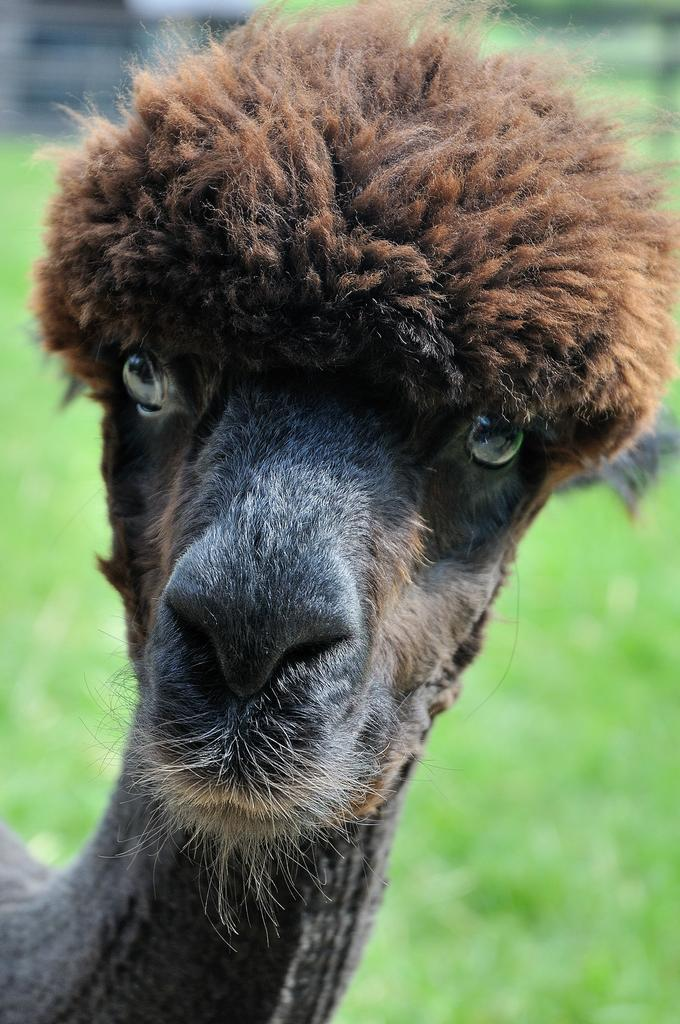What type of creature is present in the image? There is an animal in the image. What color is the animal? The animal is brown in color. What can be seen in the background of the image? The background of the image includes green grass. What type of fireman is sitting on the cushion in the image? There is no fireman or cushion present in the image; it features an animal and green grass in the background. 